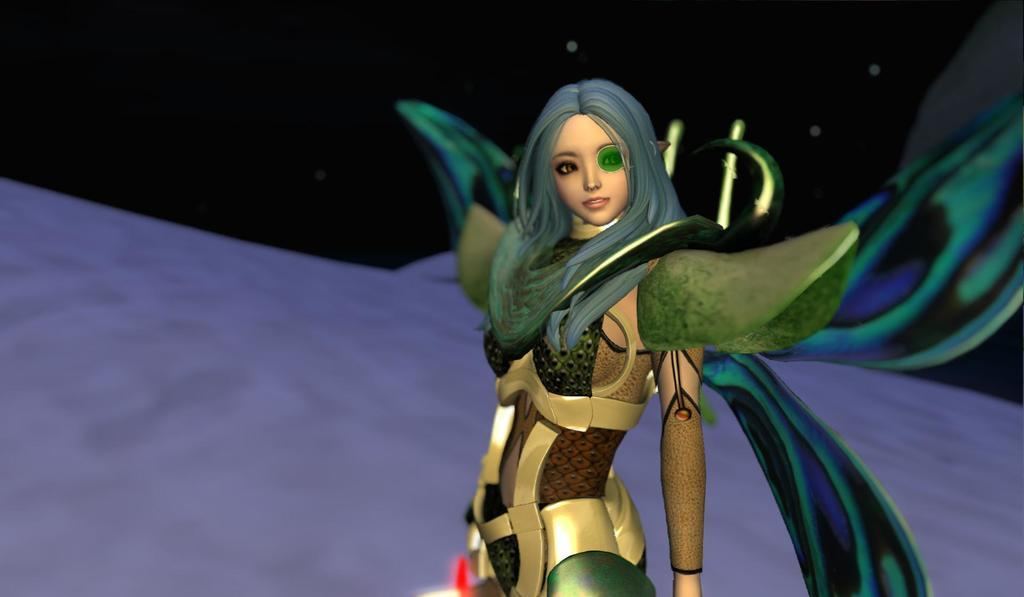What is the main subject of the image? There is a graphic in the image. Who or what is featured in the graphic? There is a woman in the image. What is the woman wearing? The woman is wearing a green and gold costume. What can be seen in the background of the image? The background of the image includes a dark sky. What type of chin can be seen on the woman in the image? There is no chin visible on the woman in the image, as it is a graphic and not a photograph. --- 